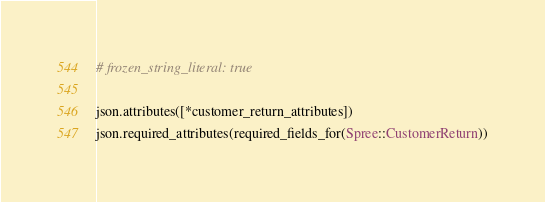<code> <loc_0><loc_0><loc_500><loc_500><_Ruby_># frozen_string_literal: true

json.attributes([*customer_return_attributes])
json.required_attributes(required_fields_for(Spree::CustomerReturn))
</code> 